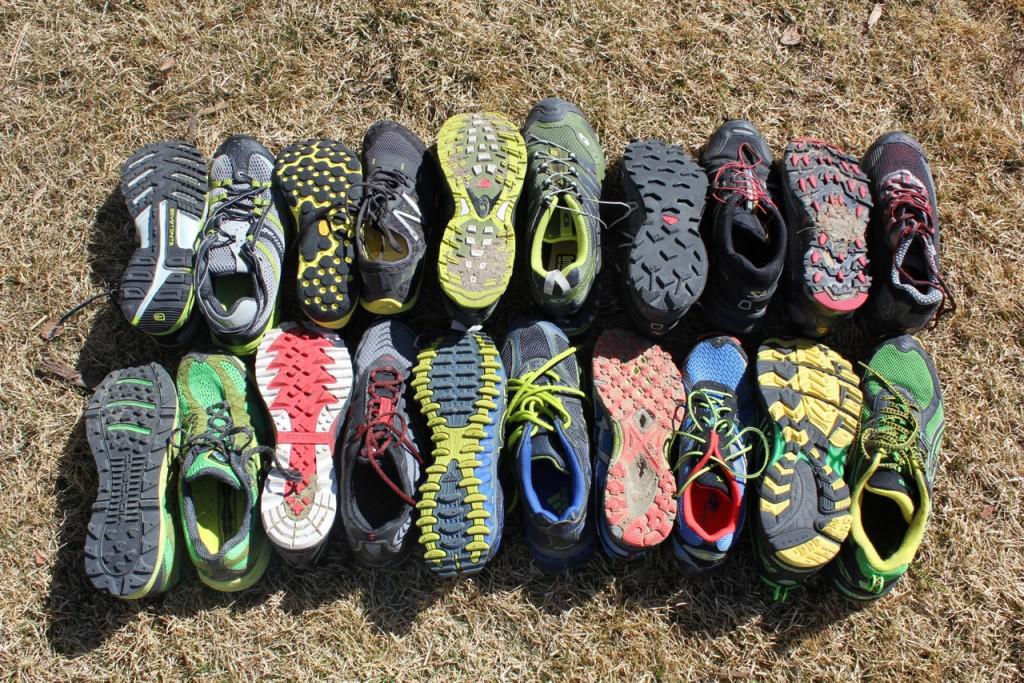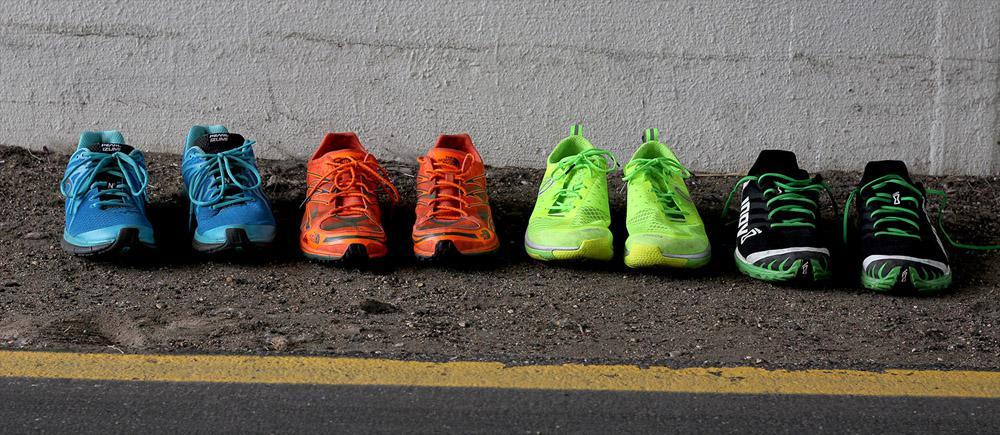The first image is the image on the left, the second image is the image on the right. Given the left and right images, does the statement "In total, no more than five individual shoes are shown." hold true? Answer yes or no. No. 